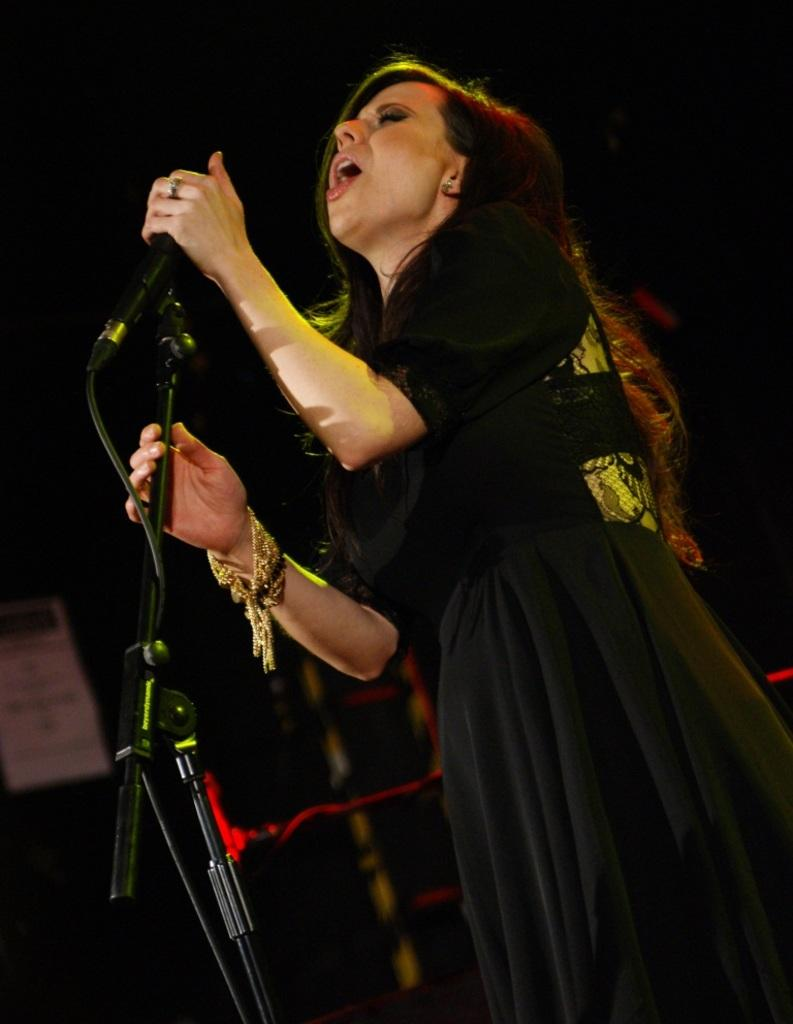Who is the main subject in the image? There is a woman in the image. What is the woman doing in the image? The woman is singing a song. What object is the woman holding in her hand? The woman is holding a microphone in her hand. What type of government is depicted in the image? There is no depiction of a government in the image; it features a woman singing with a microphone. What type of linen is being used as a backdrop in the image? There is no linen present in the image; it only shows a woman singing with a microphone. 